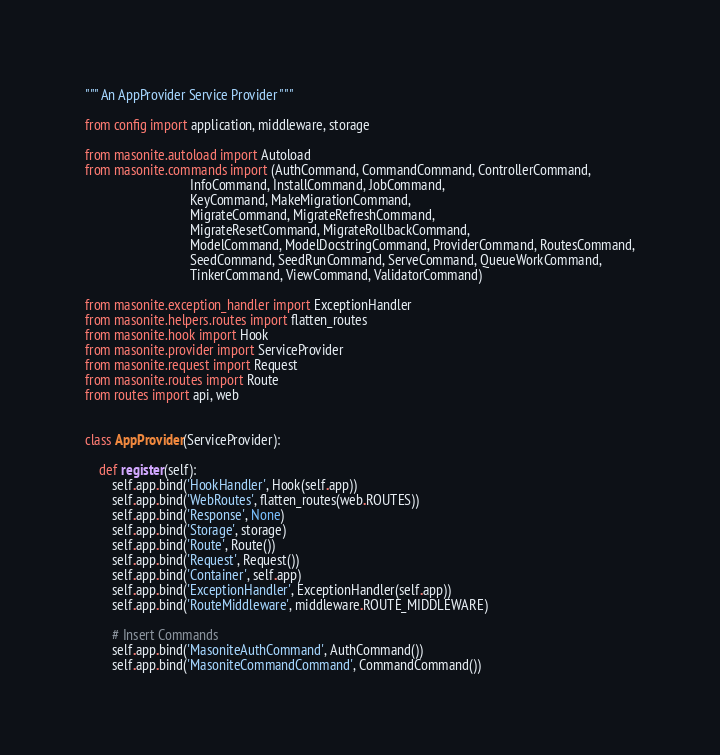<code> <loc_0><loc_0><loc_500><loc_500><_Python_>""" An AppProvider Service Provider """

from config import application, middleware, storage

from masonite.autoload import Autoload
from masonite.commands import (AuthCommand, CommandCommand, ControllerCommand,
                               InfoCommand, InstallCommand, JobCommand,
                               KeyCommand, MakeMigrationCommand,
                               MigrateCommand, MigrateRefreshCommand,
                               MigrateResetCommand, MigrateRollbackCommand,
                               ModelCommand, ModelDocstringCommand, ProviderCommand, RoutesCommand,
                               SeedCommand, SeedRunCommand, ServeCommand, QueueWorkCommand,
                               TinkerCommand, ViewCommand, ValidatorCommand)

from masonite.exception_handler import ExceptionHandler
from masonite.helpers.routes import flatten_routes
from masonite.hook import Hook
from masonite.provider import ServiceProvider
from masonite.request import Request
from masonite.routes import Route
from routes import api, web


class AppProvider(ServiceProvider):

    def register(self):
        self.app.bind('HookHandler', Hook(self.app))
        self.app.bind('WebRoutes', flatten_routes(web.ROUTES))
        self.app.bind('Response', None)
        self.app.bind('Storage', storage)
        self.app.bind('Route', Route())
        self.app.bind('Request', Request())
        self.app.bind('Container', self.app)
        self.app.bind('ExceptionHandler', ExceptionHandler(self.app))
        self.app.bind('RouteMiddleware', middleware.ROUTE_MIDDLEWARE)

        # Insert Commands
        self.app.bind('MasoniteAuthCommand', AuthCommand())
        self.app.bind('MasoniteCommandCommand', CommandCommand())</code> 